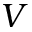<formula> <loc_0><loc_0><loc_500><loc_500>V</formula> 